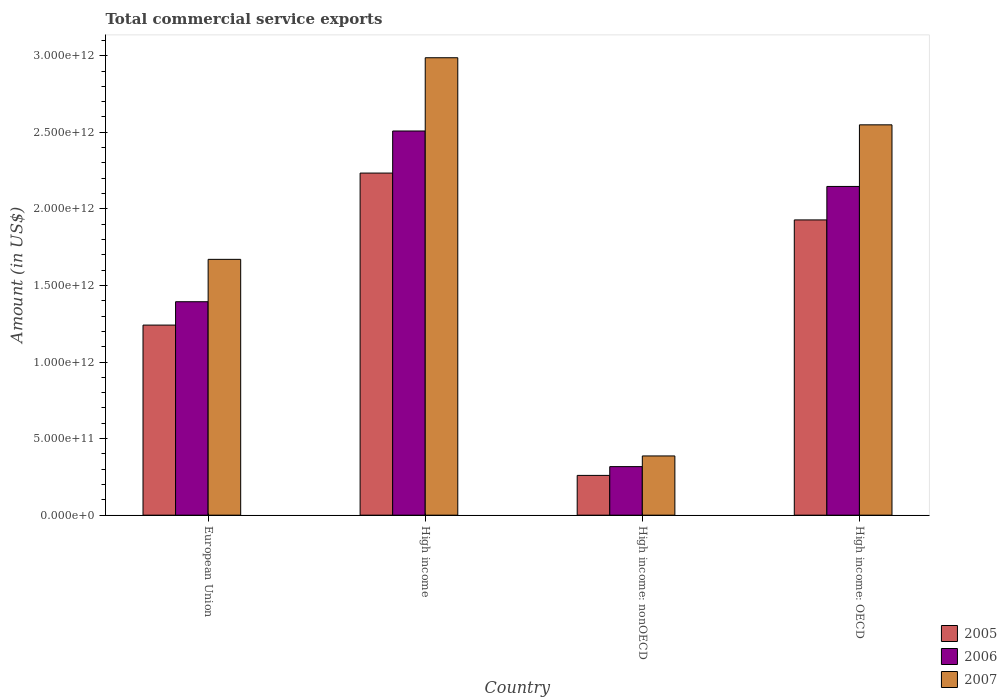How many different coloured bars are there?
Your response must be concise. 3. How many groups of bars are there?
Provide a short and direct response. 4. How many bars are there on the 2nd tick from the right?
Ensure brevity in your answer.  3. What is the label of the 3rd group of bars from the left?
Keep it short and to the point. High income: nonOECD. What is the total commercial service exports in 2006 in High income: nonOECD?
Make the answer very short. 3.17e+11. Across all countries, what is the maximum total commercial service exports in 2007?
Offer a terse response. 2.99e+12. Across all countries, what is the minimum total commercial service exports in 2006?
Give a very brief answer. 3.17e+11. In which country was the total commercial service exports in 2006 minimum?
Offer a terse response. High income: nonOECD. What is the total total commercial service exports in 2006 in the graph?
Offer a very short reply. 6.37e+12. What is the difference between the total commercial service exports in 2007 in European Union and that in High income?
Make the answer very short. -1.32e+12. What is the difference between the total commercial service exports in 2005 in High income: OECD and the total commercial service exports in 2007 in High income: nonOECD?
Provide a succinct answer. 1.54e+12. What is the average total commercial service exports in 2005 per country?
Ensure brevity in your answer.  1.42e+12. What is the difference between the total commercial service exports of/in 2007 and total commercial service exports of/in 2005 in High income: OECD?
Give a very brief answer. 6.21e+11. In how many countries, is the total commercial service exports in 2007 greater than 900000000000 US$?
Offer a terse response. 3. What is the ratio of the total commercial service exports in 2005 in European Union to that in High income: nonOECD?
Offer a very short reply. 4.78. What is the difference between the highest and the second highest total commercial service exports in 2007?
Your response must be concise. 4.38e+11. What is the difference between the highest and the lowest total commercial service exports in 2006?
Your answer should be compact. 2.19e+12. In how many countries, is the total commercial service exports in 2006 greater than the average total commercial service exports in 2006 taken over all countries?
Ensure brevity in your answer.  2. What does the 1st bar from the left in High income: nonOECD represents?
Offer a very short reply. 2005. What does the 2nd bar from the right in High income represents?
Keep it short and to the point. 2006. How many bars are there?
Provide a succinct answer. 12. Are all the bars in the graph horizontal?
Keep it short and to the point. No. What is the difference between two consecutive major ticks on the Y-axis?
Provide a succinct answer. 5.00e+11. Are the values on the major ticks of Y-axis written in scientific E-notation?
Your answer should be compact. Yes. What is the title of the graph?
Offer a very short reply. Total commercial service exports. Does "1993" appear as one of the legend labels in the graph?
Your answer should be compact. No. What is the label or title of the Y-axis?
Your answer should be very brief. Amount (in US$). What is the Amount (in US$) in 2005 in European Union?
Provide a short and direct response. 1.24e+12. What is the Amount (in US$) of 2006 in European Union?
Your answer should be very brief. 1.39e+12. What is the Amount (in US$) in 2007 in European Union?
Keep it short and to the point. 1.67e+12. What is the Amount (in US$) in 2005 in High income?
Offer a terse response. 2.23e+12. What is the Amount (in US$) in 2006 in High income?
Offer a very short reply. 2.51e+12. What is the Amount (in US$) of 2007 in High income?
Keep it short and to the point. 2.99e+12. What is the Amount (in US$) of 2005 in High income: nonOECD?
Ensure brevity in your answer.  2.60e+11. What is the Amount (in US$) in 2006 in High income: nonOECD?
Your answer should be compact. 3.17e+11. What is the Amount (in US$) of 2007 in High income: nonOECD?
Provide a succinct answer. 3.87e+11. What is the Amount (in US$) of 2005 in High income: OECD?
Your response must be concise. 1.93e+12. What is the Amount (in US$) of 2006 in High income: OECD?
Your answer should be very brief. 2.15e+12. What is the Amount (in US$) of 2007 in High income: OECD?
Give a very brief answer. 2.55e+12. Across all countries, what is the maximum Amount (in US$) in 2005?
Provide a succinct answer. 2.23e+12. Across all countries, what is the maximum Amount (in US$) of 2006?
Your answer should be compact. 2.51e+12. Across all countries, what is the maximum Amount (in US$) of 2007?
Keep it short and to the point. 2.99e+12. Across all countries, what is the minimum Amount (in US$) of 2005?
Ensure brevity in your answer.  2.60e+11. Across all countries, what is the minimum Amount (in US$) in 2006?
Your response must be concise. 3.17e+11. Across all countries, what is the minimum Amount (in US$) of 2007?
Your answer should be very brief. 3.87e+11. What is the total Amount (in US$) in 2005 in the graph?
Your answer should be compact. 5.66e+12. What is the total Amount (in US$) of 2006 in the graph?
Ensure brevity in your answer.  6.37e+12. What is the total Amount (in US$) of 2007 in the graph?
Make the answer very short. 7.59e+12. What is the difference between the Amount (in US$) of 2005 in European Union and that in High income?
Offer a very short reply. -9.93e+11. What is the difference between the Amount (in US$) in 2006 in European Union and that in High income?
Offer a terse response. -1.11e+12. What is the difference between the Amount (in US$) in 2007 in European Union and that in High income?
Provide a short and direct response. -1.32e+12. What is the difference between the Amount (in US$) in 2005 in European Union and that in High income: nonOECD?
Give a very brief answer. 9.81e+11. What is the difference between the Amount (in US$) in 2006 in European Union and that in High income: nonOECD?
Make the answer very short. 1.08e+12. What is the difference between the Amount (in US$) in 2007 in European Union and that in High income: nonOECD?
Make the answer very short. 1.28e+12. What is the difference between the Amount (in US$) of 2005 in European Union and that in High income: OECD?
Offer a terse response. -6.87e+11. What is the difference between the Amount (in US$) of 2006 in European Union and that in High income: OECD?
Offer a terse response. -7.53e+11. What is the difference between the Amount (in US$) of 2007 in European Union and that in High income: OECD?
Offer a very short reply. -8.78e+11. What is the difference between the Amount (in US$) of 2005 in High income and that in High income: nonOECD?
Offer a very short reply. 1.97e+12. What is the difference between the Amount (in US$) in 2006 in High income and that in High income: nonOECD?
Ensure brevity in your answer.  2.19e+12. What is the difference between the Amount (in US$) of 2007 in High income and that in High income: nonOECD?
Provide a short and direct response. 2.60e+12. What is the difference between the Amount (in US$) in 2005 in High income and that in High income: OECD?
Offer a terse response. 3.06e+11. What is the difference between the Amount (in US$) of 2006 in High income and that in High income: OECD?
Provide a succinct answer. 3.62e+11. What is the difference between the Amount (in US$) of 2007 in High income and that in High income: OECD?
Offer a terse response. 4.38e+11. What is the difference between the Amount (in US$) of 2005 in High income: nonOECD and that in High income: OECD?
Your answer should be compact. -1.67e+12. What is the difference between the Amount (in US$) in 2006 in High income: nonOECD and that in High income: OECD?
Keep it short and to the point. -1.83e+12. What is the difference between the Amount (in US$) in 2007 in High income: nonOECD and that in High income: OECD?
Give a very brief answer. -2.16e+12. What is the difference between the Amount (in US$) of 2005 in European Union and the Amount (in US$) of 2006 in High income?
Give a very brief answer. -1.27e+12. What is the difference between the Amount (in US$) in 2005 in European Union and the Amount (in US$) in 2007 in High income?
Ensure brevity in your answer.  -1.75e+12. What is the difference between the Amount (in US$) of 2006 in European Union and the Amount (in US$) of 2007 in High income?
Provide a succinct answer. -1.59e+12. What is the difference between the Amount (in US$) of 2005 in European Union and the Amount (in US$) of 2006 in High income: nonOECD?
Provide a short and direct response. 9.24e+11. What is the difference between the Amount (in US$) in 2005 in European Union and the Amount (in US$) in 2007 in High income: nonOECD?
Keep it short and to the point. 8.55e+11. What is the difference between the Amount (in US$) of 2006 in European Union and the Amount (in US$) of 2007 in High income: nonOECD?
Your response must be concise. 1.01e+12. What is the difference between the Amount (in US$) of 2005 in European Union and the Amount (in US$) of 2006 in High income: OECD?
Offer a very short reply. -9.05e+11. What is the difference between the Amount (in US$) of 2005 in European Union and the Amount (in US$) of 2007 in High income: OECD?
Your answer should be compact. -1.31e+12. What is the difference between the Amount (in US$) in 2006 in European Union and the Amount (in US$) in 2007 in High income: OECD?
Keep it short and to the point. -1.16e+12. What is the difference between the Amount (in US$) of 2005 in High income and the Amount (in US$) of 2006 in High income: nonOECD?
Offer a very short reply. 1.92e+12. What is the difference between the Amount (in US$) of 2005 in High income and the Amount (in US$) of 2007 in High income: nonOECD?
Provide a short and direct response. 1.85e+12. What is the difference between the Amount (in US$) in 2006 in High income and the Amount (in US$) in 2007 in High income: nonOECD?
Give a very brief answer. 2.12e+12. What is the difference between the Amount (in US$) of 2005 in High income and the Amount (in US$) of 2006 in High income: OECD?
Ensure brevity in your answer.  8.74e+1. What is the difference between the Amount (in US$) of 2005 in High income and the Amount (in US$) of 2007 in High income: OECD?
Ensure brevity in your answer.  -3.15e+11. What is the difference between the Amount (in US$) in 2006 in High income and the Amount (in US$) in 2007 in High income: OECD?
Your response must be concise. -4.02e+1. What is the difference between the Amount (in US$) in 2005 in High income: nonOECD and the Amount (in US$) in 2006 in High income: OECD?
Keep it short and to the point. -1.89e+12. What is the difference between the Amount (in US$) in 2005 in High income: nonOECD and the Amount (in US$) in 2007 in High income: OECD?
Provide a succinct answer. -2.29e+12. What is the difference between the Amount (in US$) in 2006 in High income: nonOECD and the Amount (in US$) in 2007 in High income: OECD?
Provide a succinct answer. -2.23e+12. What is the average Amount (in US$) of 2005 per country?
Give a very brief answer. 1.42e+12. What is the average Amount (in US$) in 2006 per country?
Your answer should be compact. 1.59e+12. What is the average Amount (in US$) of 2007 per country?
Give a very brief answer. 1.90e+12. What is the difference between the Amount (in US$) in 2005 and Amount (in US$) in 2006 in European Union?
Give a very brief answer. -1.53e+11. What is the difference between the Amount (in US$) of 2005 and Amount (in US$) of 2007 in European Union?
Provide a succinct answer. -4.29e+11. What is the difference between the Amount (in US$) of 2006 and Amount (in US$) of 2007 in European Union?
Provide a succinct answer. -2.77e+11. What is the difference between the Amount (in US$) of 2005 and Amount (in US$) of 2006 in High income?
Your answer should be very brief. -2.75e+11. What is the difference between the Amount (in US$) in 2005 and Amount (in US$) in 2007 in High income?
Your answer should be compact. -7.53e+11. What is the difference between the Amount (in US$) in 2006 and Amount (in US$) in 2007 in High income?
Your answer should be compact. -4.78e+11. What is the difference between the Amount (in US$) of 2005 and Amount (in US$) of 2006 in High income: nonOECD?
Provide a short and direct response. -5.73e+1. What is the difference between the Amount (in US$) of 2005 and Amount (in US$) of 2007 in High income: nonOECD?
Make the answer very short. -1.27e+11. What is the difference between the Amount (in US$) in 2006 and Amount (in US$) in 2007 in High income: nonOECD?
Your answer should be compact. -6.97e+1. What is the difference between the Amount (in US$) of 2005 and Amount (in US$) of 2006 in High income: OECD?
Keep it short and to the point. -2.19e+11. What is the difference between the Amount (in US$) in 2005 and Amount (in US$) in 2007 in High income: OECD?
Your answer should be very brief. -6.21e+11. What is the difference between the Amount (in US$) of 2006 and Amount (in US$) of 2007 in High income: OECD?
Your answer should be very brief. -4.02e+11. What is the ratio of the Amount (in US$) of 2005 in European Union to that in High income?
Make the answer very short. 0.56. What is the ratio of the Amount (in US$) in 2006 in European Union to that in High income?
Offer a very short reply. 0.56. What is the ratio of the Amount (in US$) of 2007 in European Union to that in High income?
Make the answer very short. 0.56. What is the ratio of the Amount (in US$) in 2005 in European Union to that in High income: nonOECD?
Give a very brief answer. 4.78. What is the ratio of the Amount (in US$) in 2006 in European Union to that in High income: nonOECD?
Provide a short and direct response. 4.4. What is the ratio of the Amount (in US$) in 2007 in European Union to that in High income: nonOECD?
Offer a very short reply. 4.32. What is the ratio of the Amount (in US$) in 2005 in European Union to that in High income: OECD?
Ensure brevity in your answer.  0.64. What is the ratio of the Amount (in US$) in 2006 in European Union to that in High income: OECD?
Your response must be concise. 0.65. What is the ratio of the Amount (in US$) of 2007 in European Union to that in High income: OECD?
Your answer should be compact. 0.66. What is the ratio of the Amount (in US$) in 2005 in High income to that in High income: nonOECD?
Offer a terse response. 8.6. What is the ratio of the Amount (in US$) of 2006 in High income to that in High income: nonOECD?
Offer a very short reply. 7.91. What is the ratio of the Amount (in US$) in 2007 in High income to that in High income: nonOECD?
Offer a very short reply. 7.72. What is the ratio of the Amount (in US$) in 2005 in High income to that in High income: OECD?
Offer a very short reply. 1.16. What is the ratio of the Amount (in US$) in 2006 in High income to that in High income: OECD?
Your answer should be compact. 1.17. What is the ratio of the Amount (in US$) of 2007 in High income to that in High income: OECD?
Your answer should be compact. 1.17. What is the ratio of the Amount (in US$) in 2005 in High income: nonOECD to that in High income: OECD?
Your answer should be very brief. 0.13. What is the ratio of the Amount (in US$) in 2006 in High income: nonOECD to that in High income: OECD?
Make the answer very short. 0.15. What is the ratio of the Amount (in US$) of 2007 in High income: nonOECD to that in High income: OECD?
Your response must be concise. 0.15. What is the difference between the highest and the second highest Amount (in US$) of 2005?
Your answer should be very brief. 3.06e+11. What is the difference between the highest and the second highest Amount (in US$) of 2006?
Keep it short and to the point. 3.62e+11. What is the difference between the highest and the second highest Amount (in US$) in 2007?
Give a very brief answer. 4.38e+11. What is the difference between the highest and the lowest Amount (in US$) in 2005?
Provide a succinct answer. 1.97e+12. What is the difference between the highest and the lowest Amount (in US$) of 2006?
Offer a very short reply. 2.19e+12. What is the difference between the highest and the lowest Amount (in US$) of 2007?
Your answer should be very brief. 2.60e+12. 